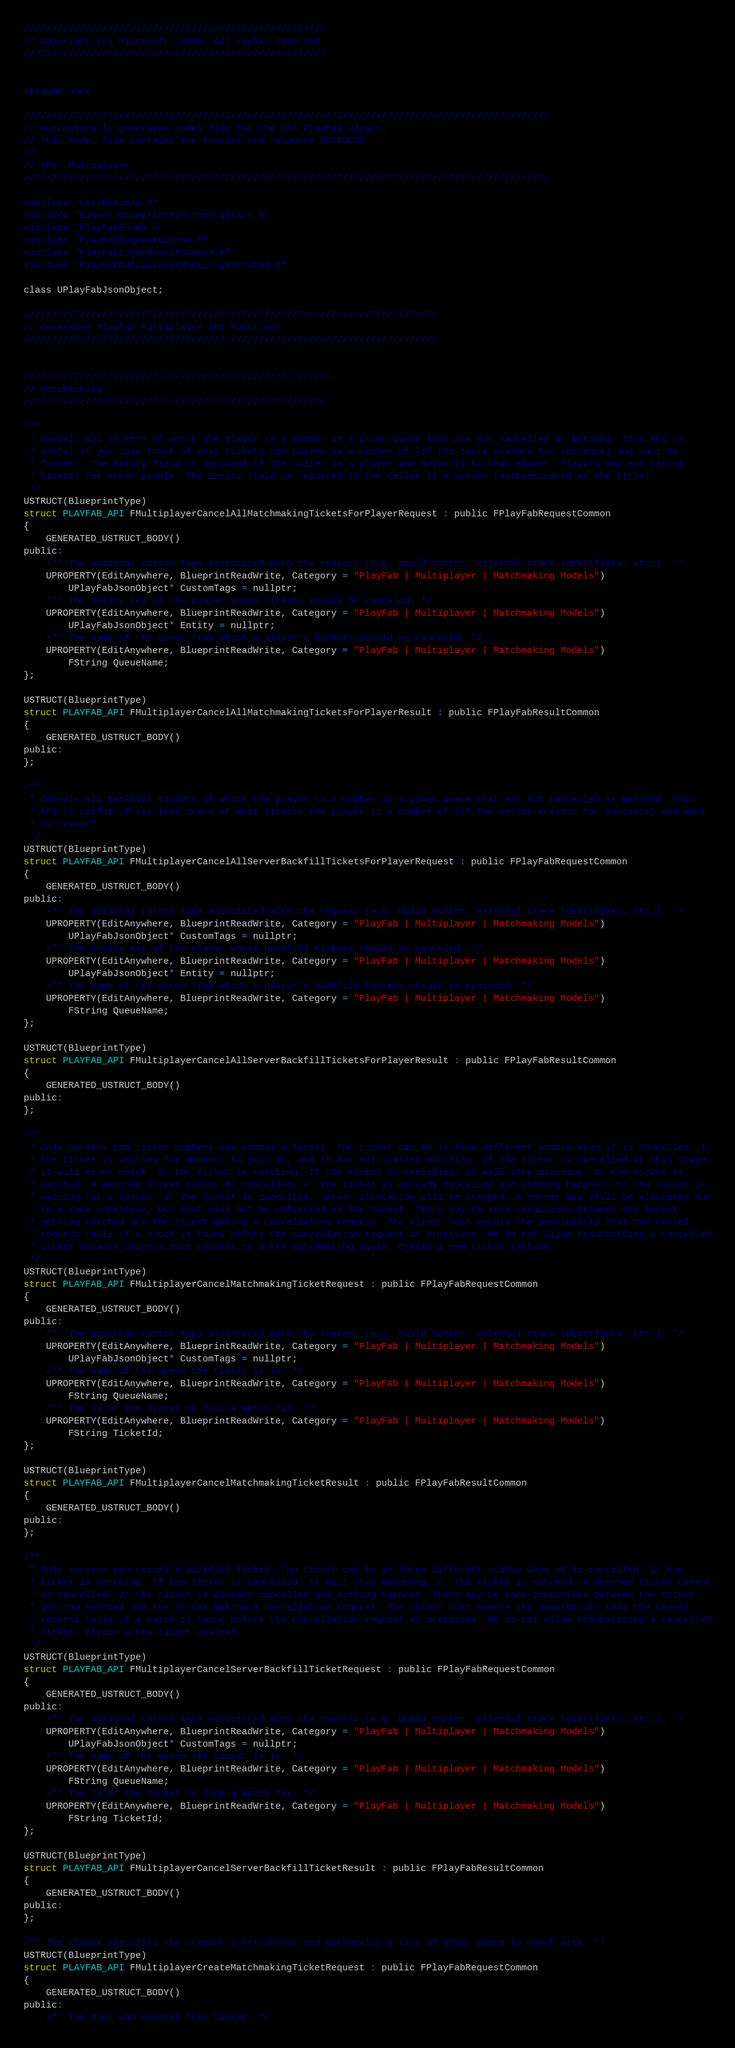<code> <loc_0><loc_0><loc_500><loc_500><_C_>//////////////////////////////////////////////////////
// Copyright (C) Microsoft. 2018. All rights reserved.
//////////////////////////////////////////////////////


#pragma once

//////////////////////////////////////////////////////////////////////////////////////////////
// Automatically generated model file for the UE4 PlayFab plugin.
// This model file contains the request and response USTRUCTS
//
// API: Multiplayer
//////////////////////////////////////////////////////////////////////////////////////////////

#include "CoreMinimal.h"
#include "Kismet/BlueprintFunctionLibrary.h"
#include "PlayFabEnums.h"
#include "PlayFabRequestCommon.h"
#include "PlayFabLoginResultCommon.h"
#include "PlayFabMultiplayerModels.generated.h"

class UPlayFabJsonObject;

//////////////////////////////////////////////////////////////////////////
// Generated PlayFab Multiplayer API Functions
//////////////////////////////////////////////////////////////////////////


///////////////////////////////////////////////////////
// Matchmaking
//////////////////////////////////////////////////////

/**
 * Cancels all tickets of which the player is a member in a given queue that are not cancelled or matched. This API is
 * useful if you lose track of what tickets the player is a member of (if the title crashes for instance) and want to
 * "reset". The Entity field is optional if the caller is a player and defaults to that player. Players may not cancel
 * tickets for other people. The Entity field is required if the caller is a server (authenticated as the title).
 */
USTRUCT(BlueprintType)
struct PLAYFAB_API FMultiplayerCancelAllMatchmakingTicketsForPlayerRequest : public FPlayFabRequestCommon
{
    GENERATED_USTRUCT_BODY()
public:
    /** The optional custom tags associated with the request (e.g. build number, external trace identifiers, etc.). */
    UPROPERTY(EditAnywhere, BlueprintReadWrite, Category = "PlayFab | Multiplayer | Matchmaking Models")
        UPlayFabJsonObject* CustomTags = nullptr;
    /** The entity key of the player whose tickets should be canceled. */
    UPROPERTY(EditAnywhere, BlueprintReadWrite, Category = "PlayFab | Multiplayer | Matchmaking Models")
        UPlayFabJsonObject* Entity = nullptr;
    /** The name of the queue from which a player's tickets should be canceled. */
    UPROPERTY(EditAnywhere, BlueprintReadWrite, Category = "PlayFab | Multiplayer | Matchmaking Models")
        FString QueueName;
};

USTRUCT(BlueprintType)
struct PLAYFAB_API FMultiplayerCancelAllMatchmakingTicketsForPlayerResult : public FPlayFabResultCommon
{
    GENERATED_USTRUCT_BODY()
public:
};

/**
 * Cancels all backfill tickets of which the player is a member in a given queue that are not cancelled or matched. This
 * API is useful if you lose track of what tickets the player is a member of (if the server crashes for instance) and want
 * to "reset".
 */
USTRUCT(BlueprintType)
struct PLAYFAB_API FMultiplayerCancelAllServerBackfillTicketsForPlayerRequest : public FPlayFabRequestCommon
{
    GENERATED_USTRUCT_BODY()
public:
    /** The optional custom tags associated with the request (e.g. build number, external trace identifiers, etc.). */
    UPROPERTY(EditAnywhere, BlueprintReadWrite, Category = "PlayFab | Multiplayer | Matchmaking Models")
        UPlayFabJsonObject* CustomTags = nullptr;
    /** The entity key of the player whose backfill tickets should be canceled. */
    UPROPERTY(EditAnywhere, BlueprintReadWrite, Category = "PlayFab | Multiplayer | Matchmaking Models")
        UPlayFabJsonObject* Entity = nullptr;
    /** The name of the queue from which a player's backfill tickets should be canceled. */
    UPROPERTY(EditAnywhere, BlueprintReadWrite, Category = "PlayFab | Multiplayer | Matchmaking Models")
        FString QueueName;
};

USTRUCT(BlueprintType)
struct PLAYFAB_API FMultiplayerCancelAllServerBackfillTicketsForPlayerResult : public FPlayFabResultCommon
{
    GENERATED_USTRUCT_BODY()
public:
};

/**
 * Only servers and ticket members can cancel a ticket. The ticket can be in five different states when it is cancelled. 1:
 * the ticket is waiting for members to join it, and it has not started matching. If the ticket is cancelled at this stage,
 * it will never match. 2: the ticket is matching. If the ticket is cancelled, it will stop matching. 3: the ticket is
 * matched. A matched ticket cannot be cancelled. 4: the ticket is already cancelled and nothing happens. 5: the ticket is
 * waiting for a server. If the ticket is cancelled, server allocation will be stopped. A server may still be allocated due
 * to a race condition, but that will not be reflected in the ticket. There may be race conditions between the ticket
 * getting matched and the client making a cancellation request. The client must handle the possibility that the cancel
 * request fails if a match is found before the cancellation request is processed. We do not allow resubmitting a cancelled
 * ticket because players must consent to enter matchmaking again. Create a new ticket instead.
 */
USTRUCT(BlueprintType)
struct PLAYFAB_API FMultiplayerCancelMatchmakingTicketRequest : public FPlayFabRequestCommon
{
    GENERATED_USTRUCT_BODY()
public:
    /** The optional custom tags associated with the request (e.g. build number, external trace identifiers, etc.). */
    UPROPERTY(EditAnywhere, BlueprintReadWrite, Category = "PlayFab | Multiplayer | Matchmaking Models")
        UPlayFabJsonObject* CustomTags = nullptr;
    /** The name of the queue the ticket is in. */
    UPROPERTY(EditAnywhere, BlueprintReadWrite, Category = "PlayFab | Multiplayer | Matchmaking Models")
        FString QueueName;
    /** The Id of the ticket to find a match for. */
    UPROPERTY(EditAnywhere, BlueprintReadWrite, Category = "PlayFab | Multiplayer | Matchmaking Models")
        FString TicketId;
};

USTRUCT(BlueprintType)
struct PLAYFAB_API FMultiplayerCancelMatchmakingTicketResult : public FPlayFabResultCommon
{
    GENERATED_USTRUCT_BODY()
public:
};

/**
 * Only servers can cancel a backfill ticket. The ticket can be in three different states when it is cancelled. 1: the
 * ticket is matching. If the ticket is cancelled, it will stop matching. 2: the ticket is matched. A matched ticket cannot
 * be cancelled. 3: the ticket is already cancelled and nothing happens. There may be race conditions between the ticket
 * getting matched and the server making a cancellation request. The server must handle the possibility that the cancel
 * request fails if a match is found before the cancellation request is processed. We do not allow resubmitting a cancelled
 * ticket. Create a new ticket instead.
 */
USTRUCT(BlueprintType)
struct PLAYFAB_API FMultiplayerCancelServerBackfillTicketRequest : public FPlayFabRequestCommon
{
    GENERATED_USTRUCT_BODY()
public:
    /** The optional custom tags associated with the request (e.g. build number, external trace identifiers, etc.). */
    UPROPERTY(EditAnywhere, BlueprintReadWrite, Category = "PlayFab | Multiplayer | Matchmaking Models")
        UPlayFabJsonObject* CustomTags = nullptr;
    /** The name of the queue the ticket is in. */
    UPROPERTY(EditAnywhere, BlueprintReadWrite, Category = "PlayFab | Multiplayer | Matchmaking Models")
        FString QueueName;
    /** The Id of the ticket to find a match for. */
    UPROPERTY(EditAnywhere, BlueprintReadWrite, Category = "PlayFab | Multiplayer | Matchmaking Models")
        FString TicketId;
};

USTRUCT(BlueprintType)
struct PLAYFAB_API FMultiplayerCancelServerBackfillTicketResult : public FPlayFabResultCommon
{
    GENERATED_USTRUCT_BODY()
public:
};

/** The client specifies the creator's attributes and optionally a list of other users to match with. */
USTRUCT(BlueprintType)
struct PLAYFAB_API FMultiplayerCreateMatchmakingTicketRequest : public FPlayFabRequestCommon
{
    GENERATED_USTRUCT_BODY()
public:
    /** The User who created this ticket. */</code> 